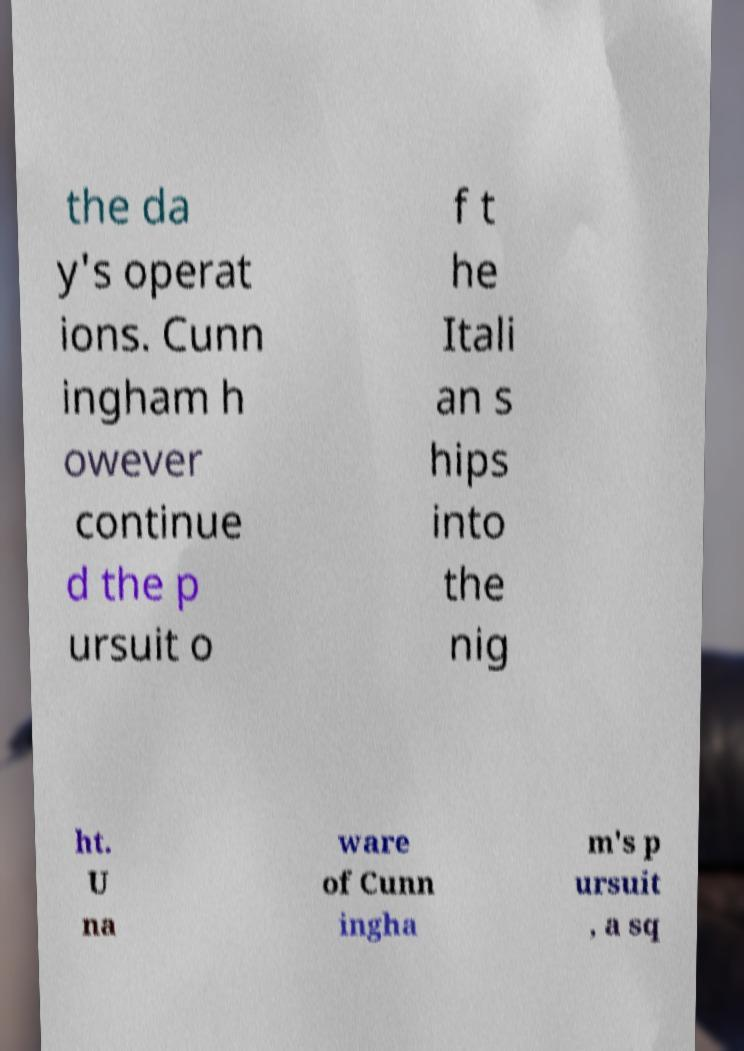There's text embedded in this image that I need extracted. Can you transcribe it verbatim? the da y's operat ions. Cunn ingham h owever continue d the p ursuit o f t he Itali an s hips into the nig ht. U na ware of Cunn ingha m's p ursuit , a sq 